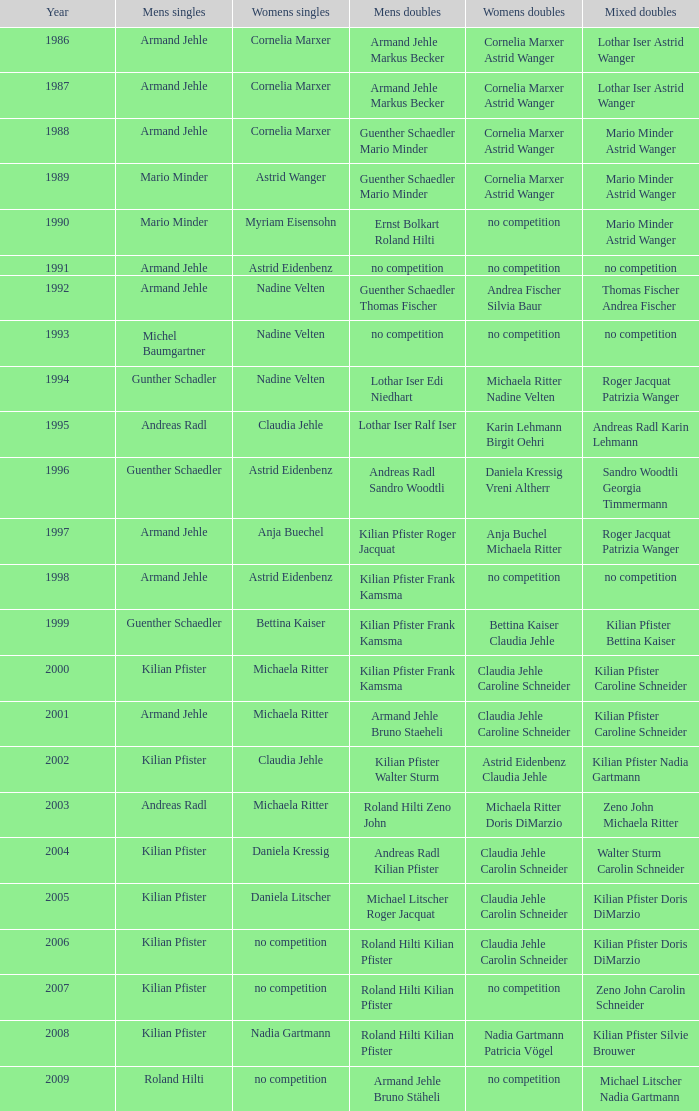In the year 2006, the womens singles had no competition and the mens doubles were roland hilti kilian pfister, what were the womens doubles Claudia Jehle Carolin Schneider. 